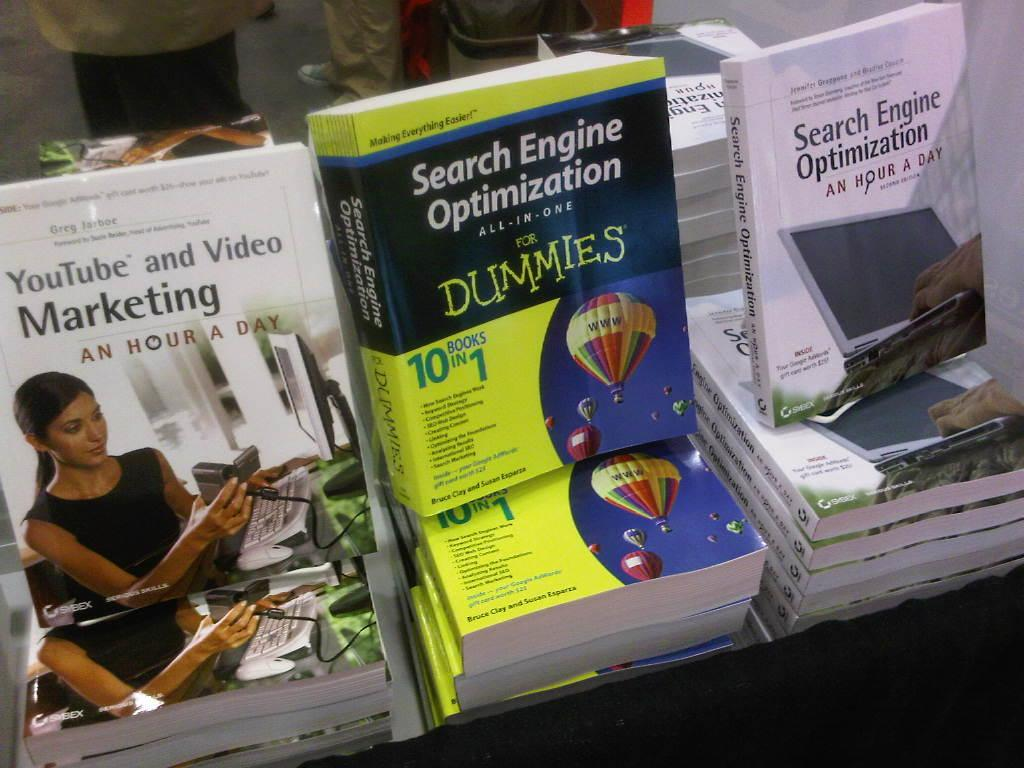<image>
Write a terse but informative summary of the picture. A couple of books about Search Engine Optimization are displayed. 